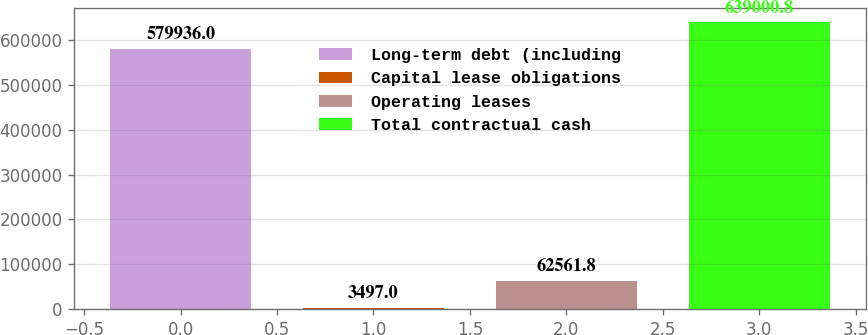Convert chart to OTSL. <chart><loc_0><loc_0><loc_500><loc_500><bar_chart><fcel>Long-term debt (including<fcel>Capital lease obligations<fcel>Operating leases<fcel>Total contractual cash<nl><fcel>579936<fcel>3497<fcel>62561.8<fcel>639001<nl></chart> 